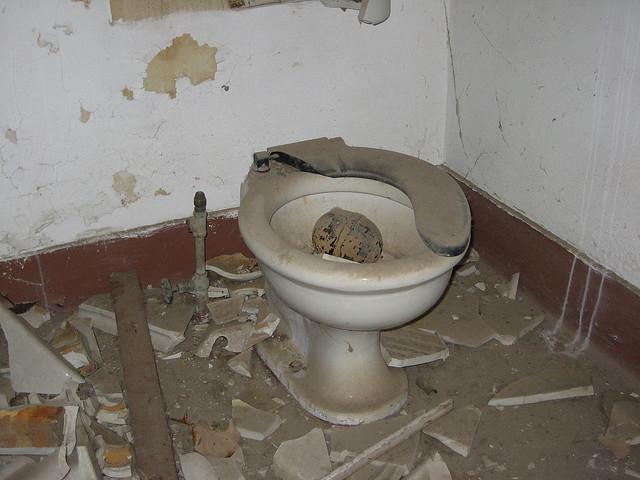Is this room functional?
Keep it brief. No. Does the bathroom need fixing?
Be succinct. Yes. Is there a seat on the toilet?
Concise answer only. No. 